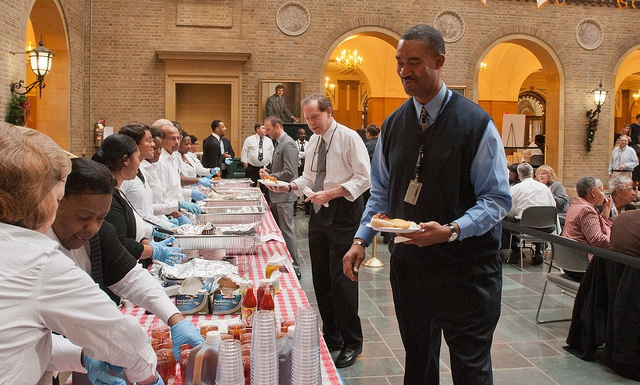Describe the objects in this image and their specific colors. I can see people in gray, black, maroon, and darkgray tones, dining table in gray, darkgray, lightgray, lightpink, and brown tones, people in gray, darkgray, and lightgray tones, people in gray, black, maroon, brown, and lightgray tones, and people in gray, black, darkgray, and lightgray tones in this image. 